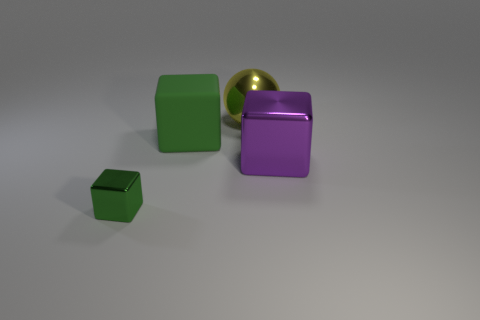How is the lighting affecting the appearance of the objects? The lighting in the image casts soft shadows beneath the objects, suggesting a diffuse light source above. The shiny surfaces of the yellow ball and the purple cube reflect the light, highlighting their glossy textures. The light enhances the three-dimensional effect of the objects and contributes to the overall calm and balanced atmosphere of the scene. Are there any other interesting details about the image that you observe? Yes, although the image is relatively simple, the smooth surfaces of the objects and the shadows they cast create a minimalist aesthetic. The reflections on the glossy ball and the purple cube add depth, and there's a subtle gradient on the background surface that shifts from light to darker grey, which adds to the image's visual interest. 